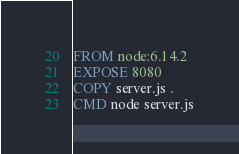<code> <loc_0><loc_0><loc_500><loc_500><_Dockerfile_>
FROM node:6.14.2
EXPOSE 8080
COPY server.js .
CMD node server.js
</code> 